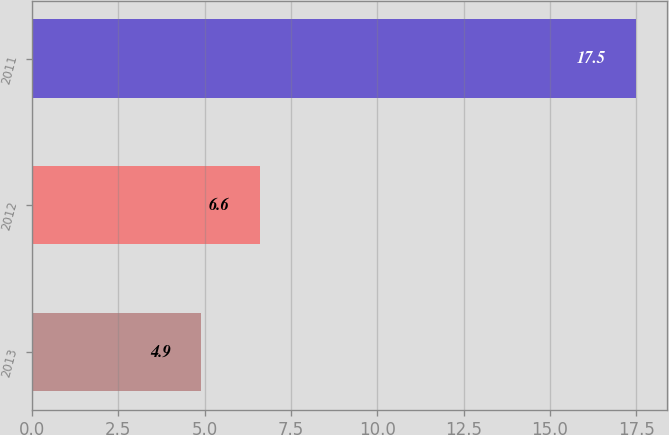Convert chart to OTSL. <chart><loc_0><loc_0><loc_500><loc_500><bar_chart><fcel>2013<fcel>2012<fcel>2011<nl><fcel>4.9<fcel>6.6<fcel>17.5<nl></chart> 